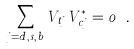Convert formula to latex. <formula><loc_0><loc_0><loc_500><loc_500>\sum _ { j = d , s , b } V _ { t j } V _ { c j } ^ { * } = 0 \ .</formula> 